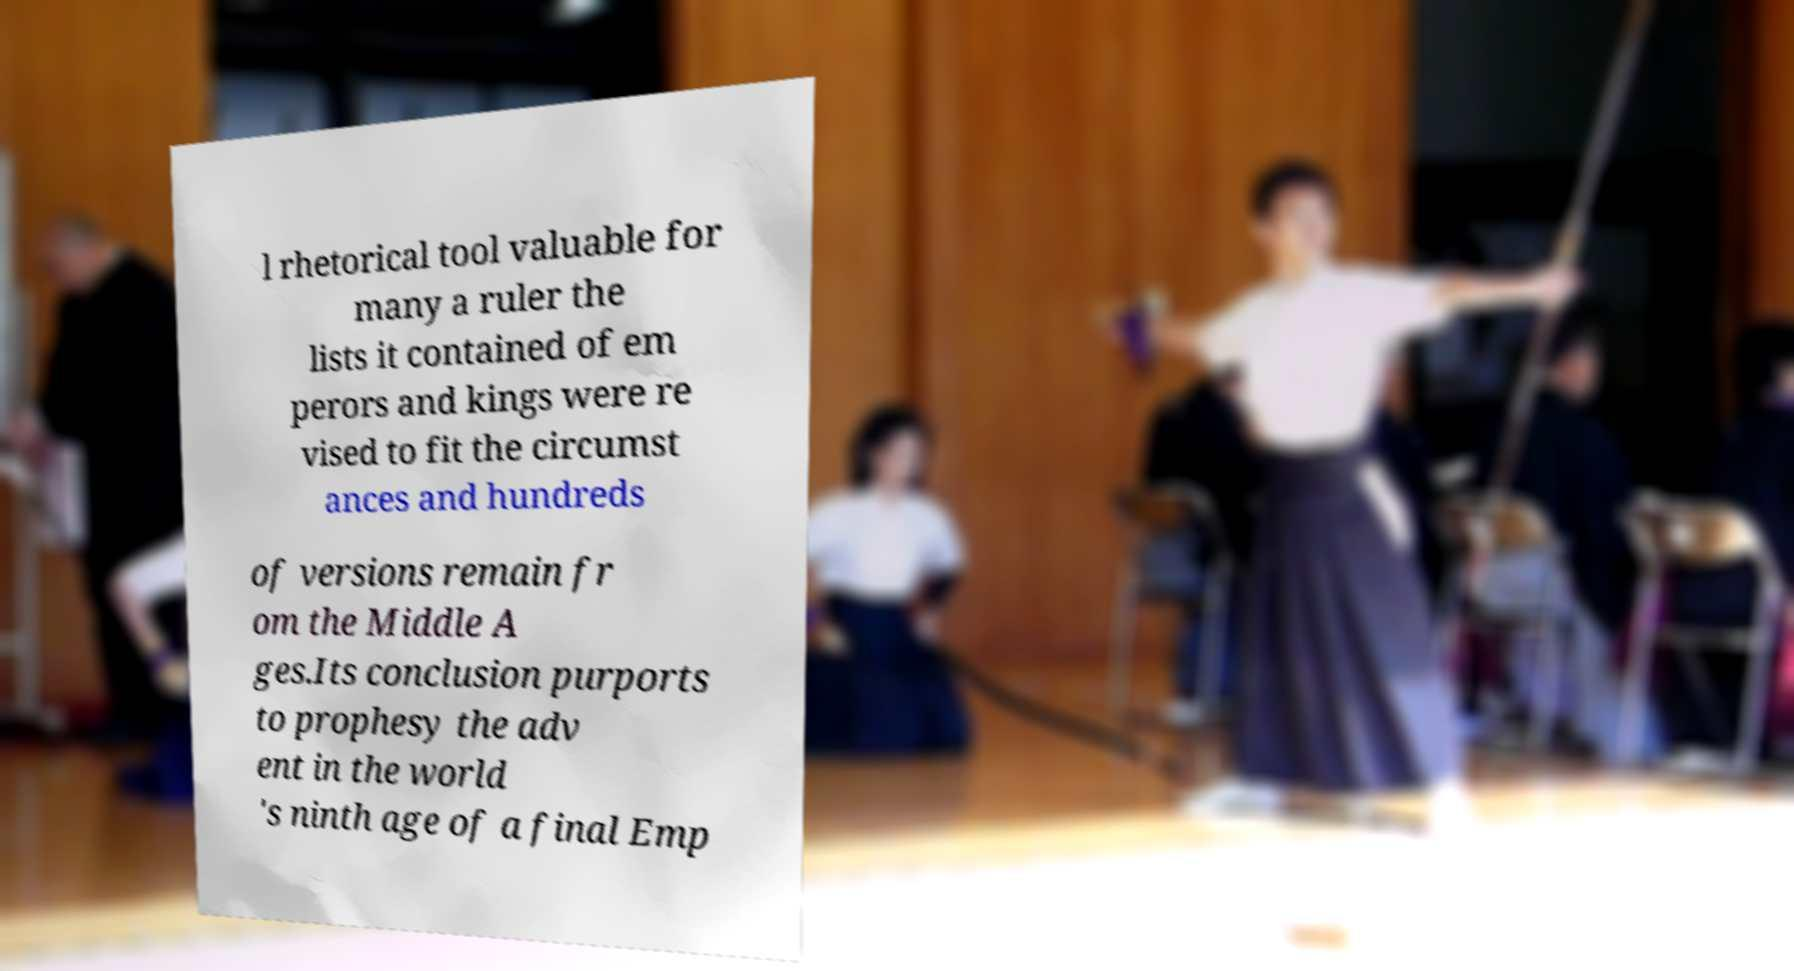Can you read and provide the text displayed in the image?This photo seems to have some interesting text. Can you extract and type it out for me? l rhetorical tool valuable for many a ruler the lists it contained of em perors and kings were re vised to fit the circumst ances and hundreds of versions remain fr om the Middle A ges.Its conclusion purports to prophesy the adv ent in the world 's ninth age of a final Emp 